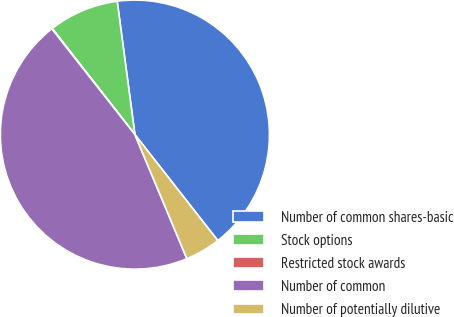<chart> <loc_0><loc_0><loc_500><loc_500><pie_chart><fcel>Number of common shares-basic<fcel>Stock options<fcel>Restricted stock awards<fcel>Number of common<fcel>Number of potentially dilutive<nl><fcel>41.53%<fcel>8.43%<fcel>0.07%<fcel>45.71%<fcel>4.25%<nl></chart> 